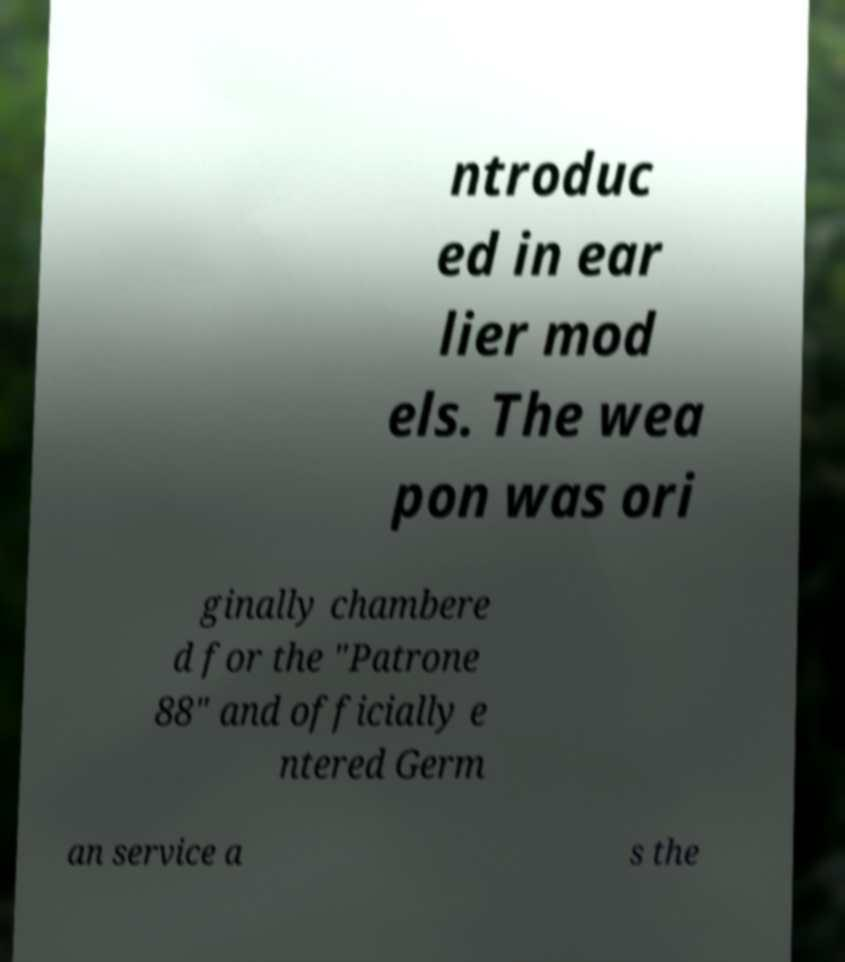Could you extract and type out the text from this image? ntroduc ed in ear lier mod els. The wea pon was ori ginally chambere d for the "Patrone 88" and officially e ntered Germ an service a s the 